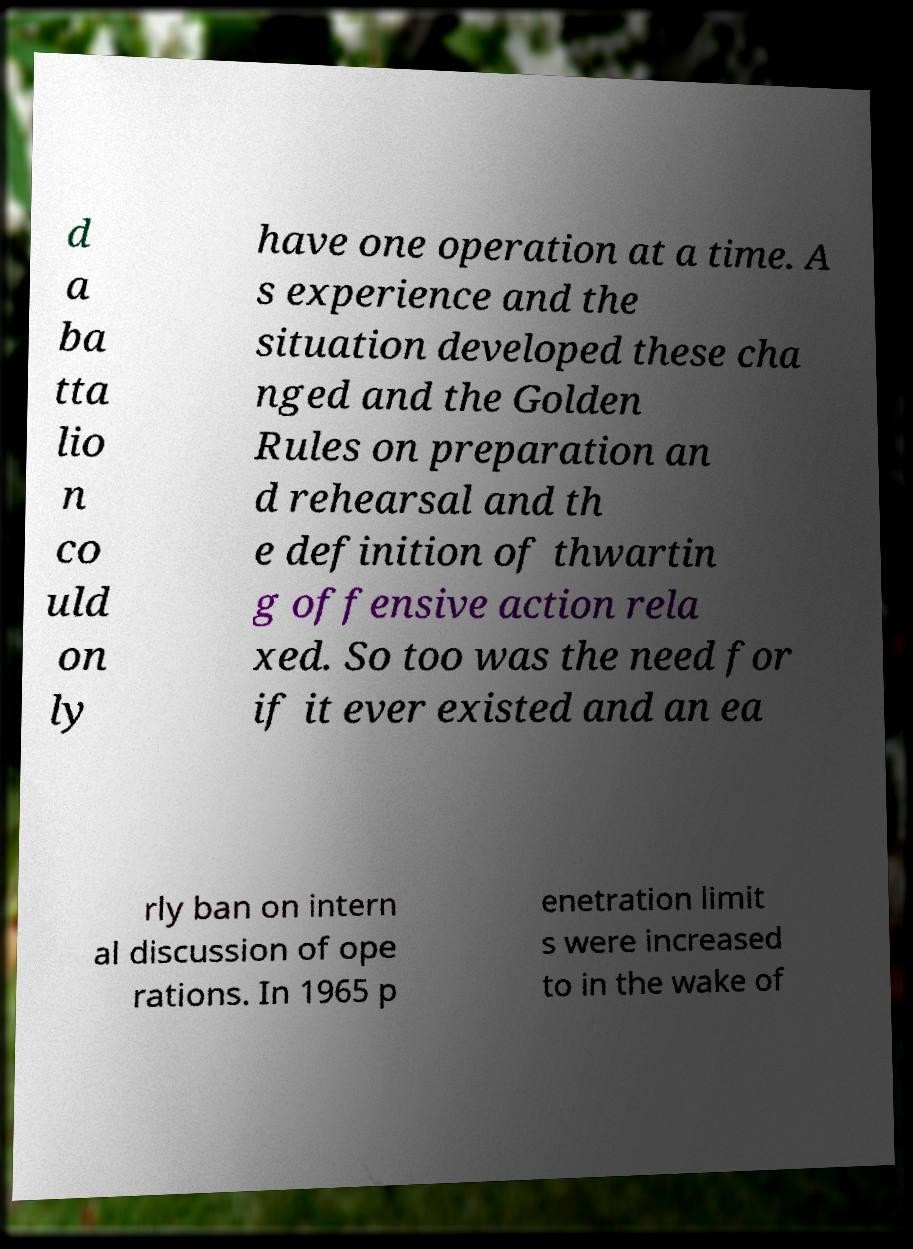Please read and relay the text visible in this image. What does it say? d a ba tta lio n co uld on ly have one operation at a time. A s experience and the situation developed these cha nged and the Golden Rules on preparation an d rehearsal and th e definition of thwartin g offensive action rela xed. So too was the need for if it ever existed and an ea rly ban on intern al discussion of ope rations. In 1965 p enetration limit s were increased to in the wake of 